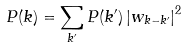<formula> <loc_0><loc_0><loc_500><loc_500>P ( k ) = \sum _ { k ^ { \prime } } P ( k ^ { \prime } ) \left | w _ { k - k ^ { \prime } } \right | ^ { 2 }</formula> 